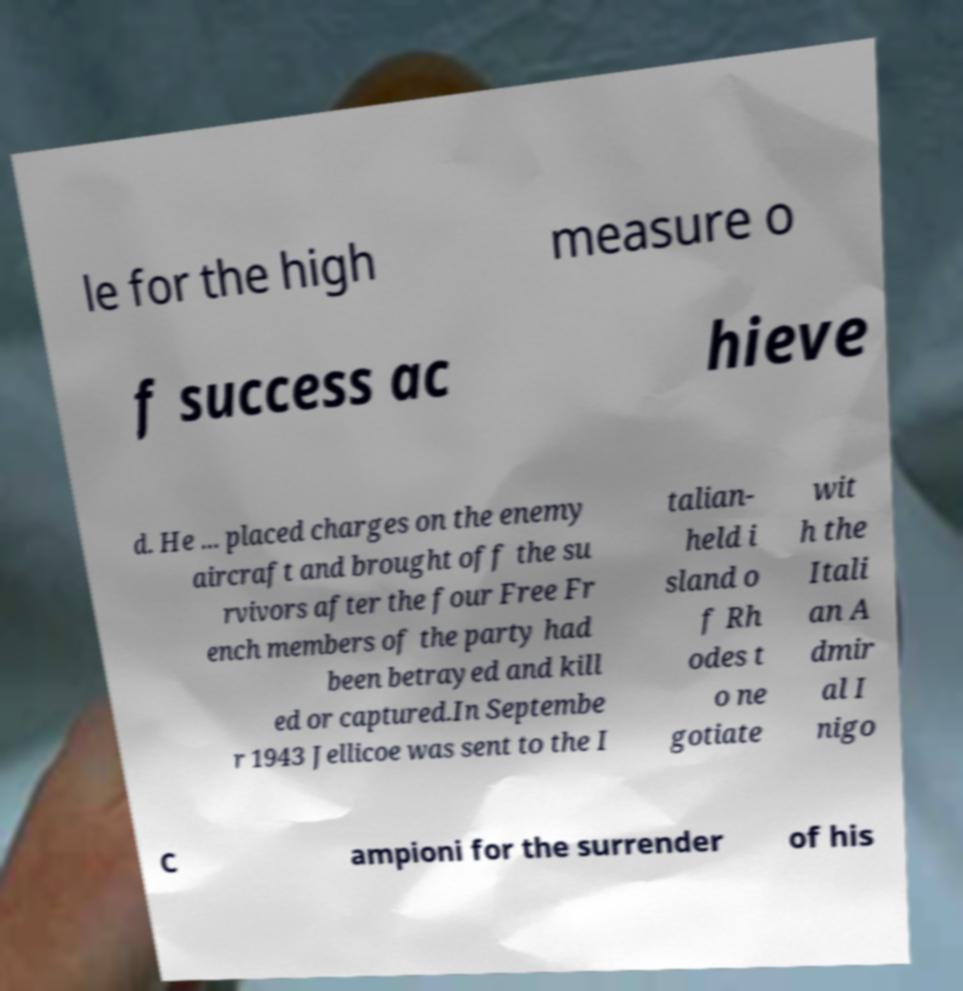Could you assist in decoding the text presented in this image and type it out clearly? le for the high measure o f success ac hieve d. He ... placed charges on the enemy aircraft and brought off the su rvivors after the four Free Fr ench members of the party had been betrayed and kill ed or captured.In Septembe r 1943 Jellicoe was sent to the I talian- held i sland o f Rh odes t o ne gotiate wit h the Itali an A dmir al I nigo C ampioni for the surrender of his 